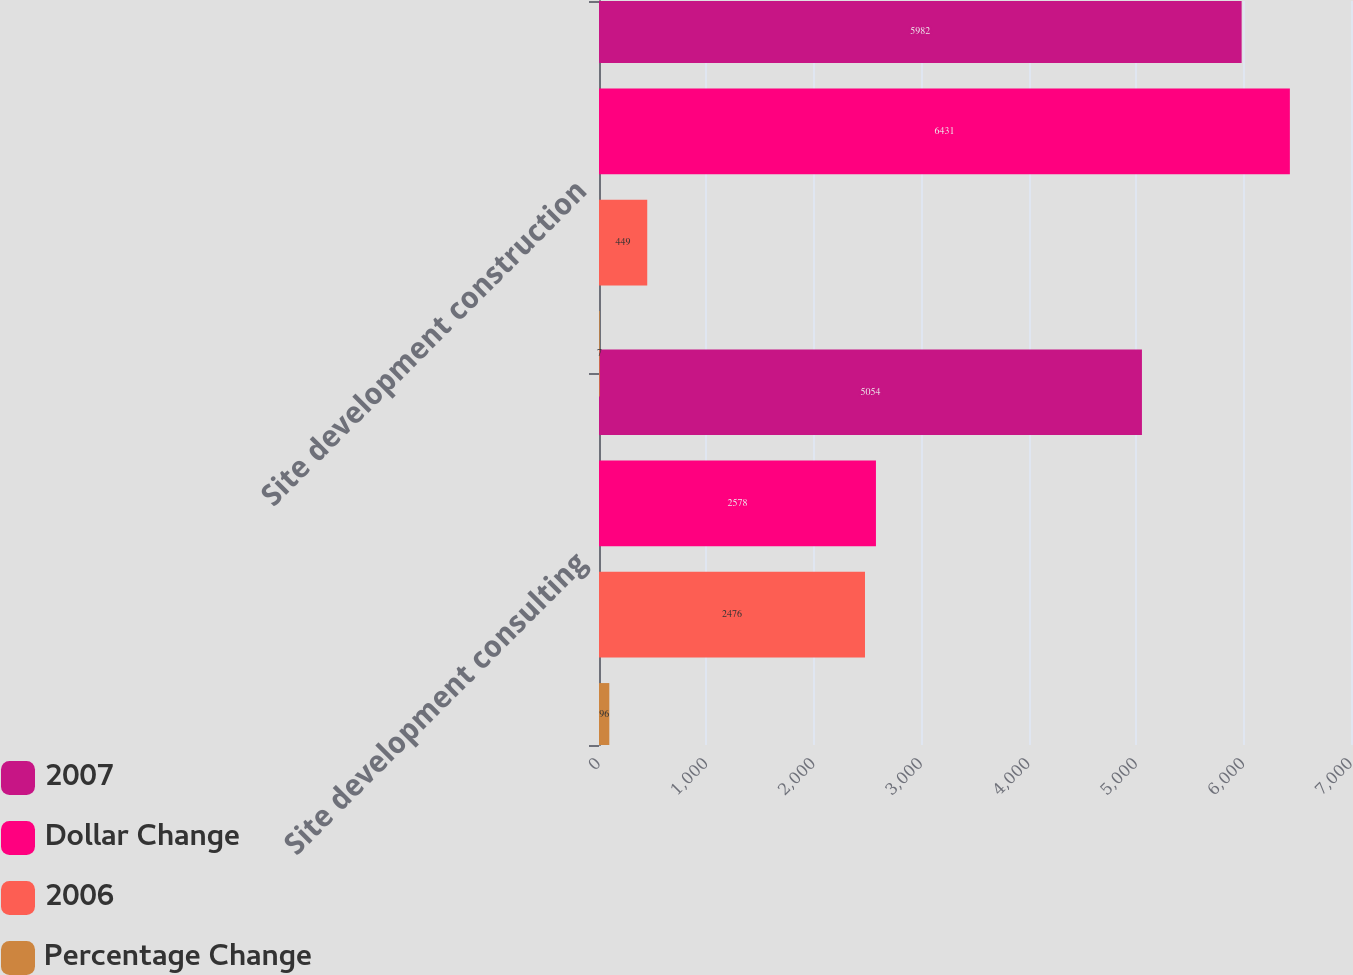Convert chart. <chart><loc_0><loc_0><loc_500><loc_500><stacked_bar_chart><ecel><fcel>Site development consulting<fcel>Site development construction<nl><fcel>2007<fcel>5054<fcel>5982<nl><fcel>Dollar Change<fcel>2578<fcel>6431<nl><fcel>2006<fcel>2476<fcel>449<nl><fcel>Percentage Change<fcel>96<fcel>7<nl></chart> 